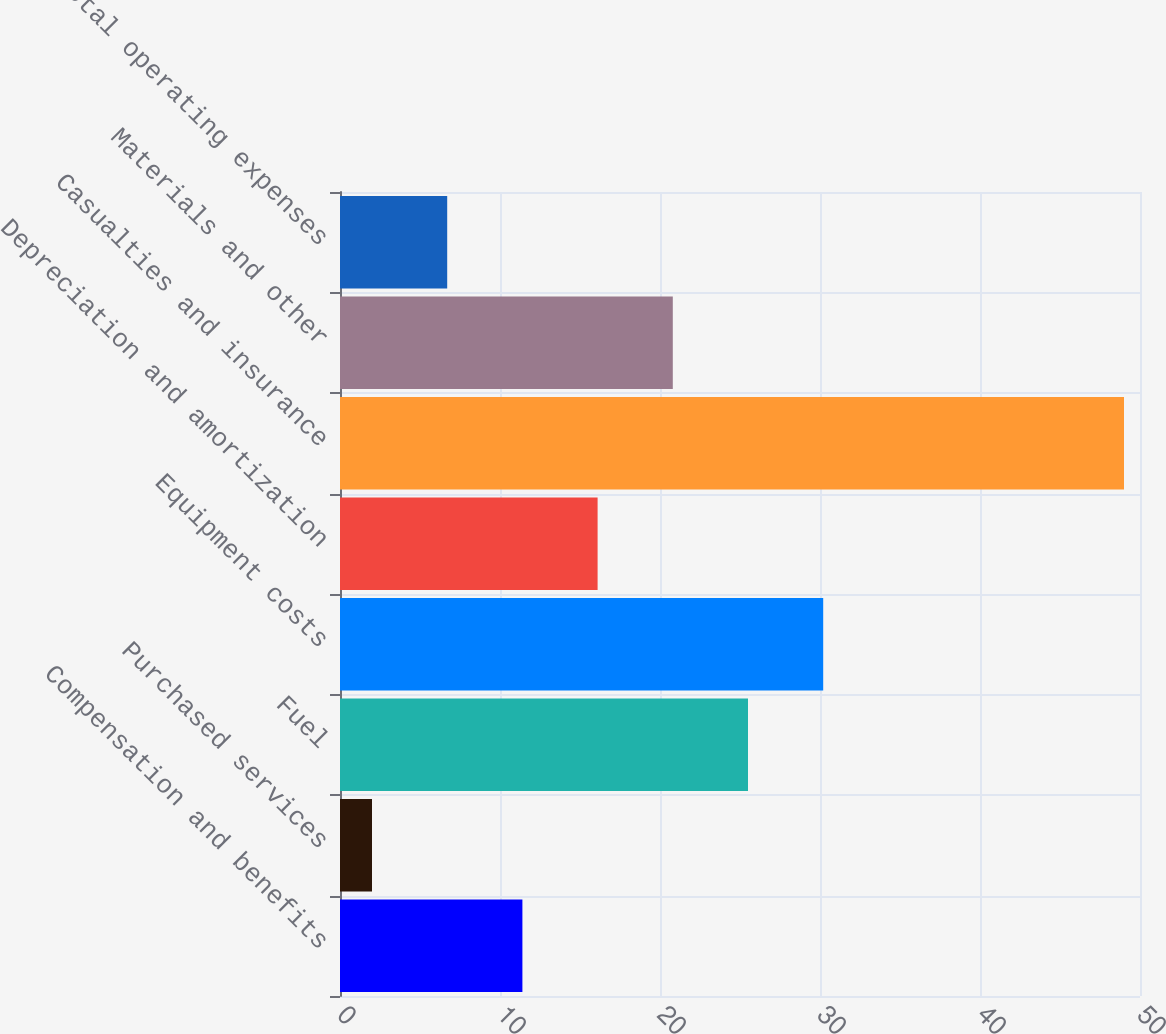<chart> <loc_0><loc_0><loc_500><loc_500><bar_chart><fcel>Compensation and benefits<fcel>Purchased services<fcel>Fuel<fcel>Equipment costs<fcel>Depreciation and amortization<fcel>Casualties and insurance<fcel>Materials and other<fcel>Total operating expenses<nl><fcel>11.4<fcel>2<fcel>25.5<fcel>30.2<fcel>16.1<fcel>49<fcel>20.8<fcel>6.7<nl></chart> 